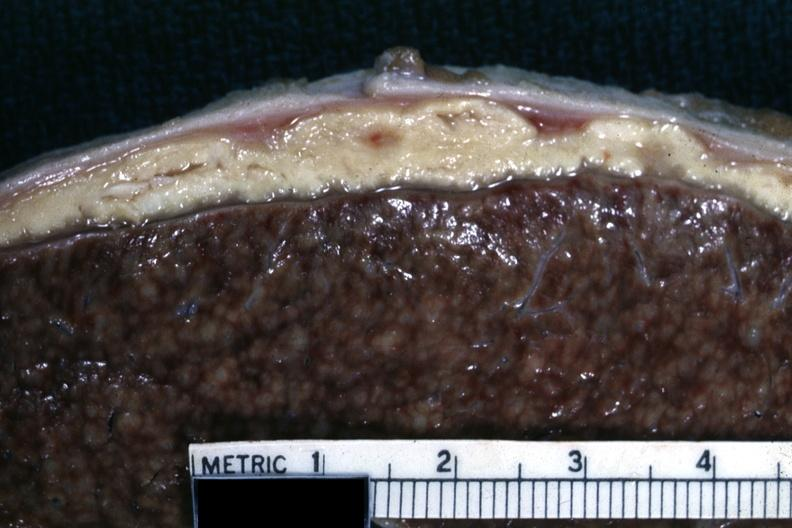what does this image show?
Answer the question using a single word or phrase. Close-up of liver with typical gray caseous looking material that can be seen with tuberculous peritonitis 